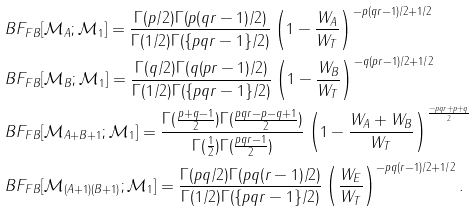<formula> <loc_0><loc_0><loc_500><loc_500>& B F _ { F B } [ \mathcal { M } _ { A } ; \mathcal { M } _ { 1 } ] = \frac { \Gamma ( p / 2 ) \Gamma ( p ( q r - 1 ) / 2 ) } { \Gamma ( 1 / 2 ) \Gamma ( \{ p q r - 1 \} / 2 ) } \left ( 1 - \frac { W _ { A } } { W _ { T } } \right ) ^ { - p ( q r - 1 ) / 2 + 1 / 2 } \\ & B F _ { F B } [ \mathcal { M } _ { B } ; \mathcal { M } _ { 1 } ] = \frac { \Gamma ( q / 2 ) \Gamma ( q ( p r - 1 ) / 2 ) } { \Gamma ( 1 / 2 ) \Gamma ( \{ p q r - 1 \} / 2 ) } \left ( 1 - \frac { W _ { B } } { W _ { T } } \right ) ^ { - q ( p r - 1 ) / 2 + 1 / 2 } \\ & B F _ { F B } [ \mathcal { M } _ { A + B + 1 } ; \mathcal { M } _ { 1 } ] = \frac { \Gamma ( \frac { p + q - 1 } { 2 } ) \Gamma ( \frac { p q r - p - q + 1 } { 2 } ) } { \Gamma ( \frac { 1 } { 2 } ) \Gamma ( \frac { p q r - 1 } { 2 } ) } \left ( 1 - \frac { W _ { A } + W _ { B } } { W _ { T } } \right ) ^ { \frac { - p q r + p + q } { 2 } } \\ & B F _ { F B } [ \mathcal { M } _ { ( A + 1 ) ( B + 1 ) } ; \mathcal { M } _ { 1 } ] = \frac { \Gamma ( p q / 2 ) \Gamma ( p q ( r - 1 ) / 2 ) } { \Gamma ( 1 / 2 ) \Gamma ( \{ p q r - 1 \} / 2 ) } \left ( \frac { W _ { E } } { W _ { T } } \right ) ^ { - p q ( r - 1 ) / 2 + 1 / 2 } .</formula> 